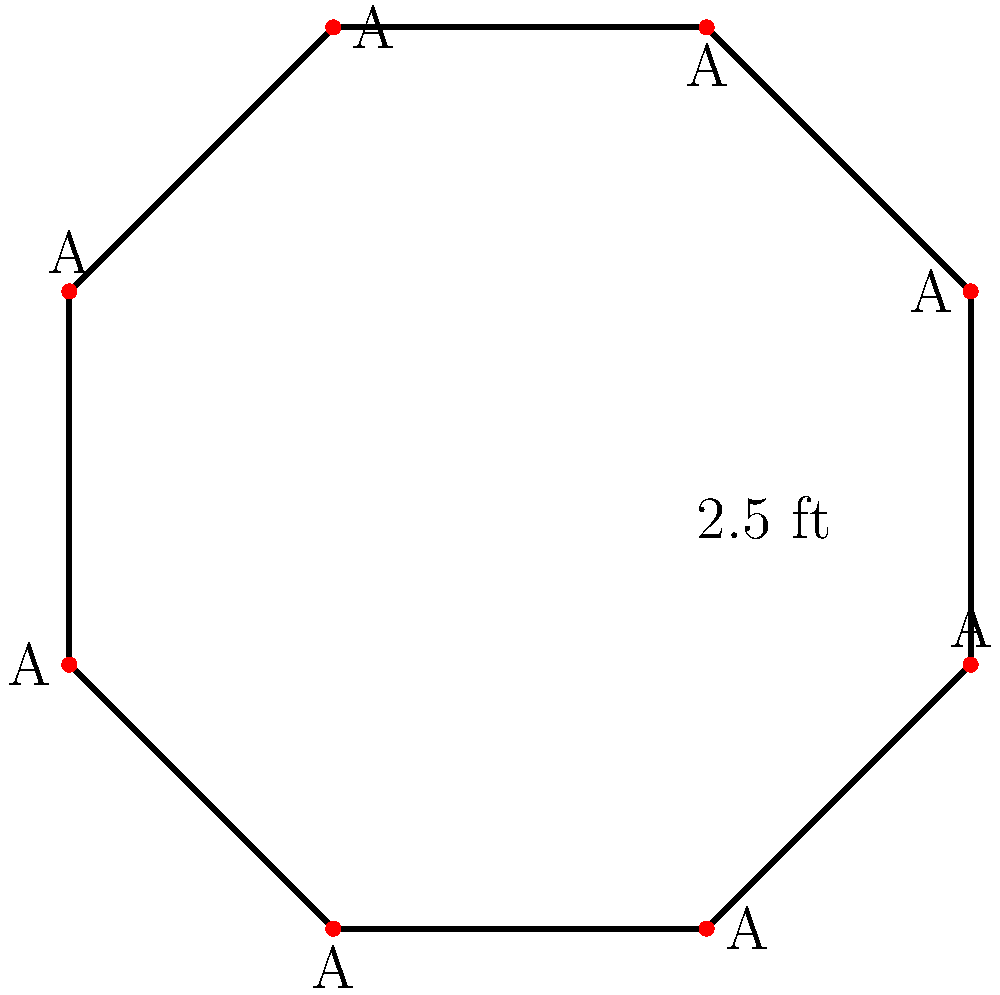In your new neighborhood, you notice an octagonal stop sign. Each side of the sign is 2.5 feet long. What is the perimeter of this stop sign in feet? Let's approach this step-by-step:

1) First, recall that perimeter is the distance around the outside of a shape.

2) For any regular polygon, the perimeter is calculated by multiplying the length of one side by the number of sides.

3) In this case:
   - The shape is an octagon, which has 8 sides
   - Each side is 2.5 feet long

4) So, we can calculate the perimeter using this formula:
   
   $$ \text{Perimeter} = \text{Number of sides} \times \text{Length of one side} $$

5) Plugging in our values:

   $$ \text{Perimeter} = 8 \times 2.5\text{ ft} $$

6) Now, let's multiply:

   $$ \text{Perimeter} = 20\text{ ft} $$

Therefore, the perimeter of the octagonal stop sign is 20 feet.
Answer: 20 ft 